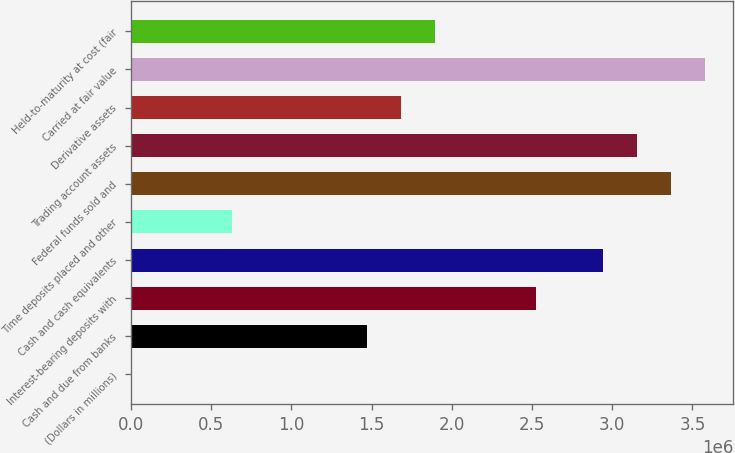Convert chart to OTSL. <chart><loc_0><loc_0><loc_500><loc_500><bar_chart><fcel>(Dollars in millions)<fcel>Cash and due from banks<fcel>Interest-bearing deposits with<fcel>Cash and cash equivalents<fcel>Time deposits placed and other<fcel>Federal funds sold and<fcel>Trading account assets<fcel>Derivative assets<fcel>Carried at fair value<fcel>Held-to-maturity at cost (fair<nl><fcel>2014<fcel>1.47378e+06<fcel>2.52504e+06<fcel>2.94554e+06<fcel>632770<fcel>3.36605e+06<fcel>3.15579e+06<fcel>1.68403e+06<fcel>3.5763e+06<fcel>1.89428e+06<nl></chart> 